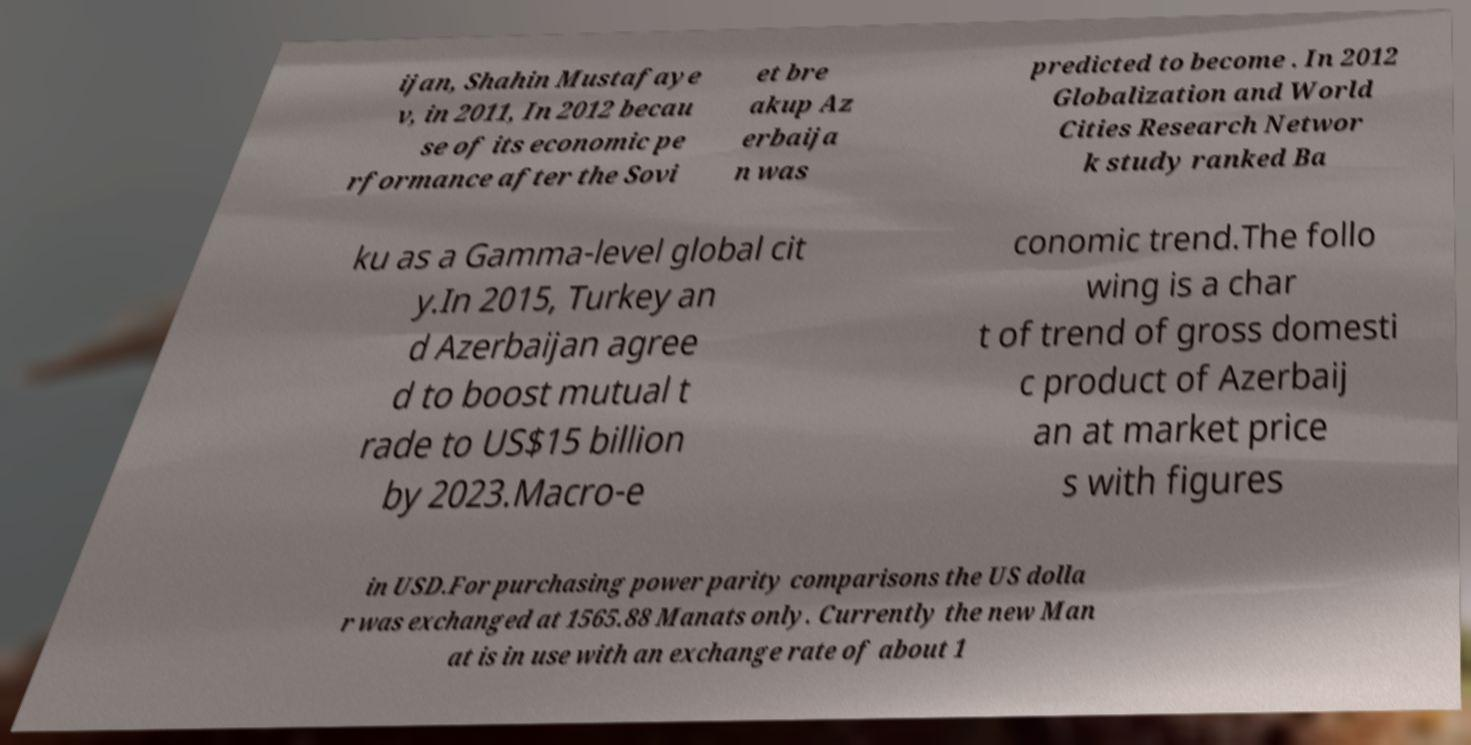Please read and relay the text visible in this image. What does it say? ijan, Shahin Mustafaye v, in 2011, In 2012 becau se of its economic pe rformance after the Sovi et bre akup Az erbaija n was predicted to become . In 2012 Globalization and World Cities Research Networ k study ranked Ba ku as a Gamma-level global cit y.In 2015, Turkey an d Azerbaijan agree d to boost mutual t rade to US$15 billion by 2023.Macro-e conomic trend.The follo wing is a char t of trend of gross domesti c product of Azerbaij an at market price s with figures in USD.For purchasing power parity comparisons the US dolla r was exchanged at 1565.88 Manats only. Currently the new Man at is in use with an exchange rate of about 1 